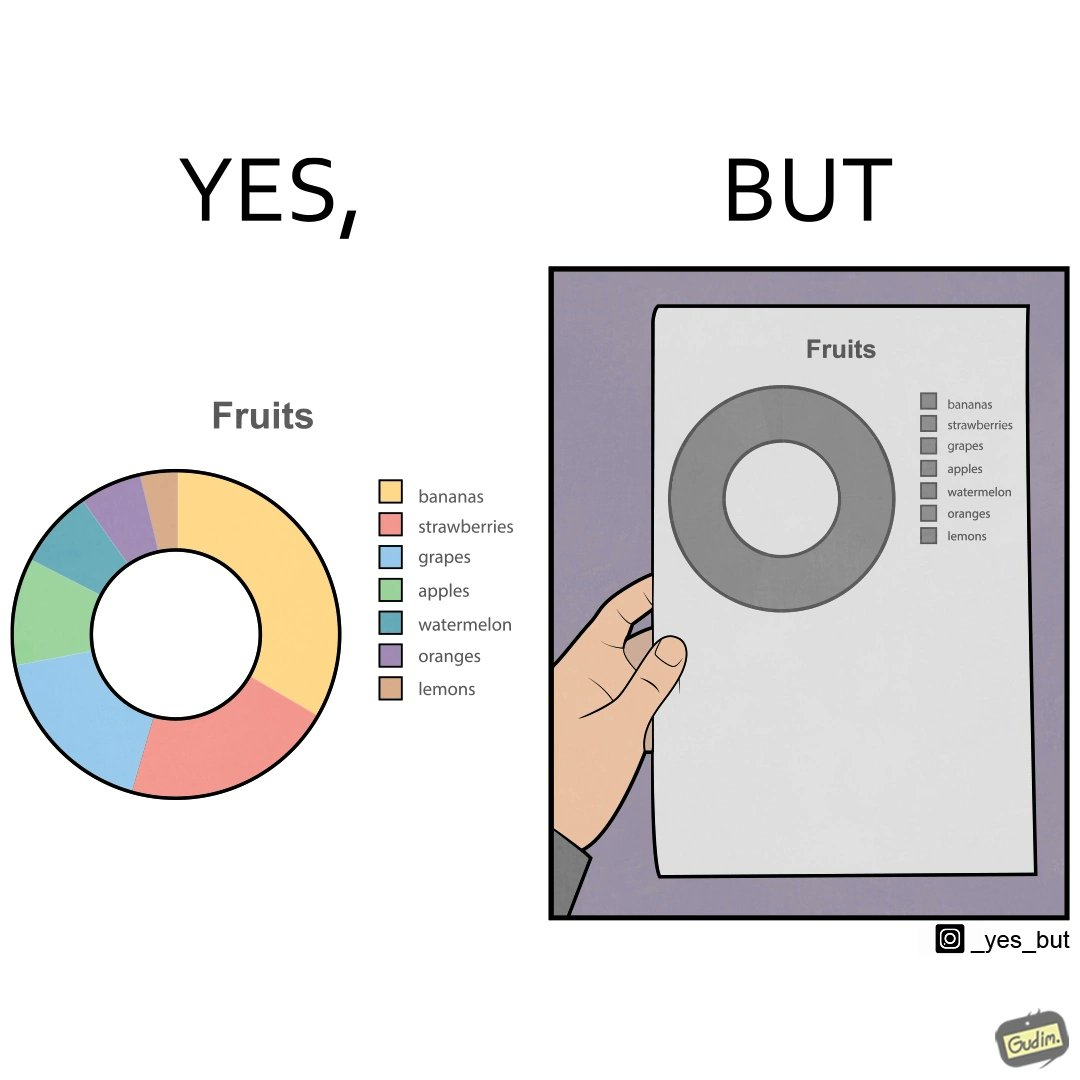Describe the contrast between the left and right parts of this image. In the left part of the image: A colorful pie chart titled "Fruits", with different distributions of various fruits like bananas, strawberries, grapes, apples, watermelon, oranges and lemons. In the right part of the image: A BLACK and WHITE greyscale printout of a pie chart titled "Fruits". The pie chart is just one circle with no divisions, but there is a key beside it that mentions various fruits like bananas, strawberries, grapes, apples, watermelon, oranges and lemons. 